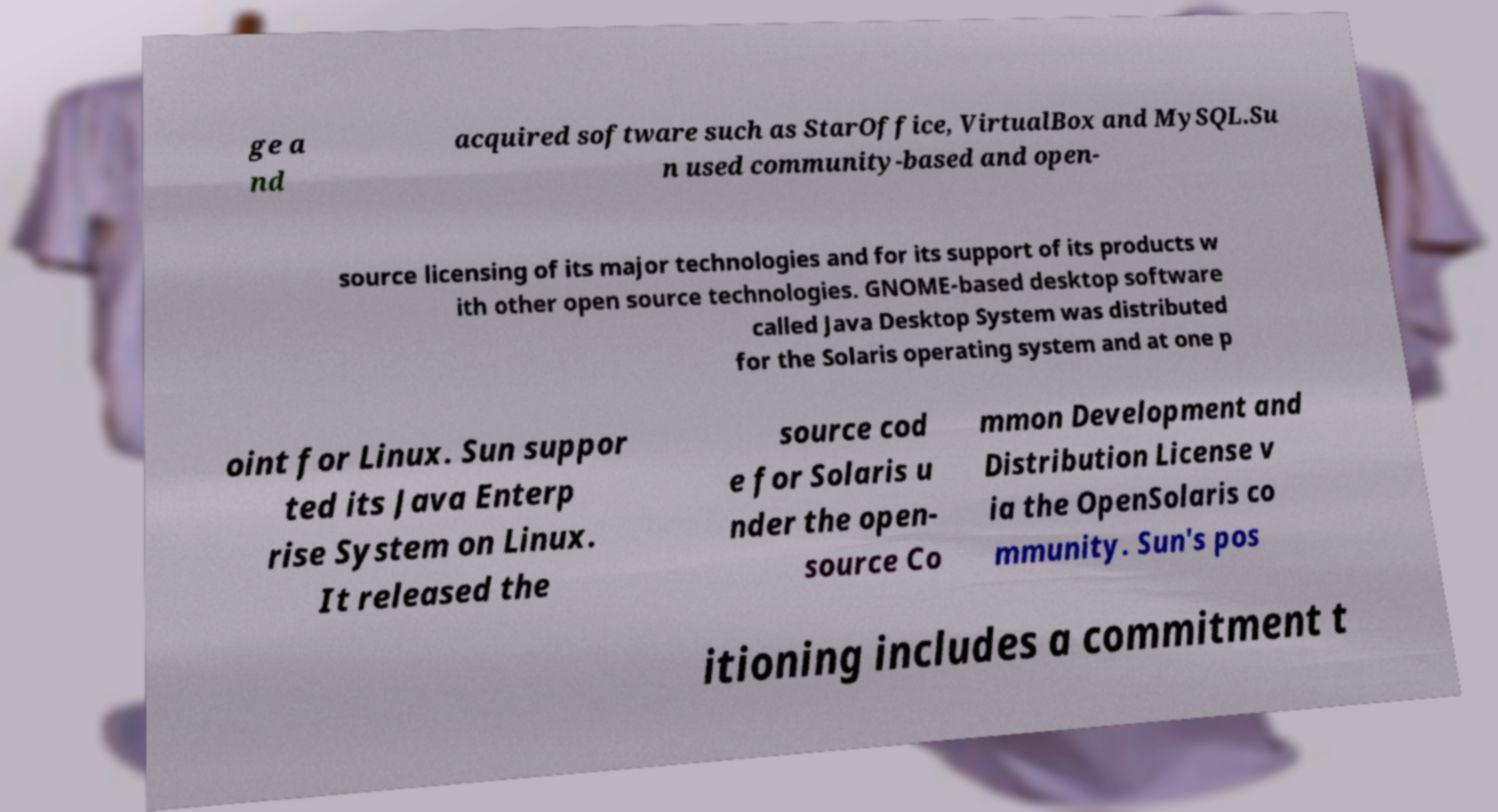There's text embedded in this image that I need extracted. Can you transcribe it verbatim? ge a nd acquired software such as StarOffice, VirtualBox and MySQL.Su n used community-based and open- source licensing of its major technologies and for its support of its products w ith other open source technologies. GNOME-based desktop software called Java Desktop System was distributed for the Solaris operating system and at one p oint for Linux. Sun suppor ted its Java Enterp rise System on Linux. It released the source cod e for Solaris u nder the open- source Co mmon Development and Distribution License v ia the OpenSolaris co mmunity. Sun's pos itioning includes a commitment t 